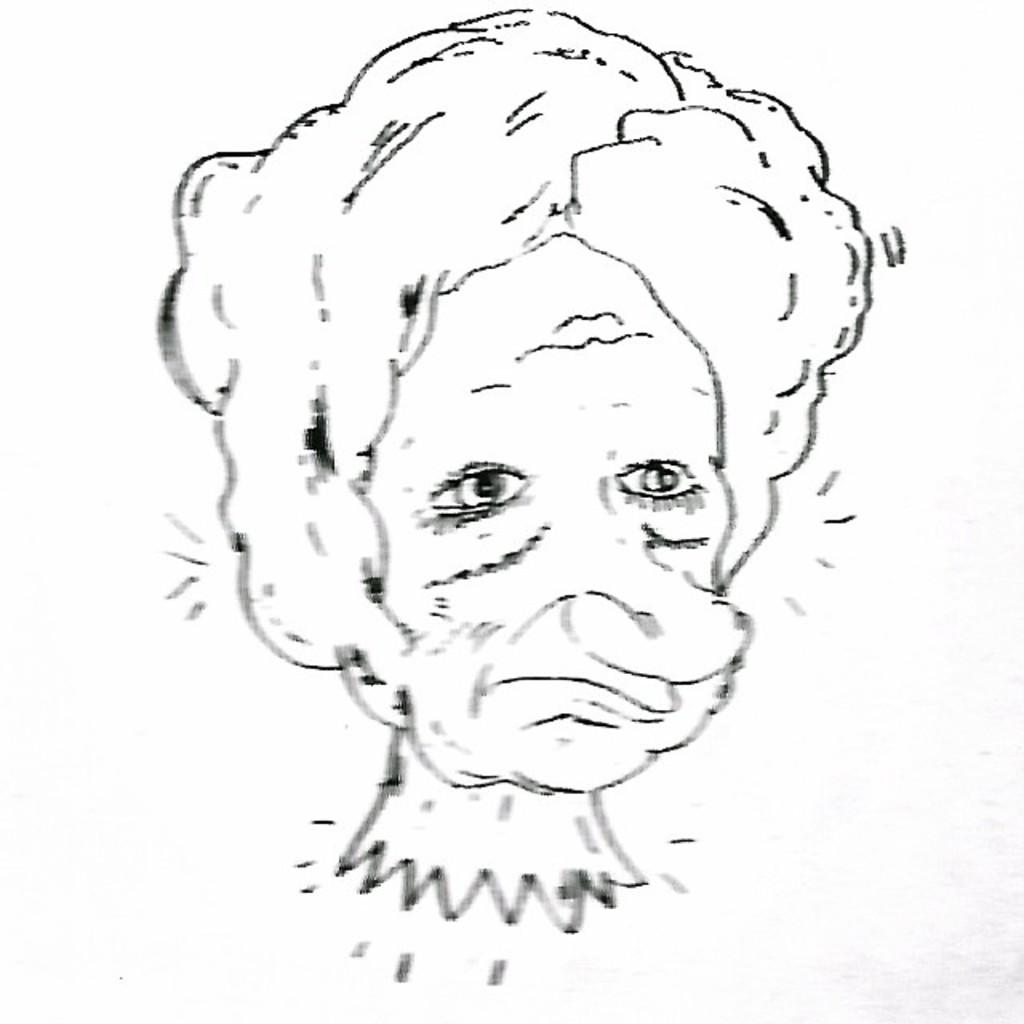What is depicted in the image? There is a drawing of a person in the image. What type of table is used to cover the drawing in the image? There is no table present in the image, as it only features a drawing of a person. 